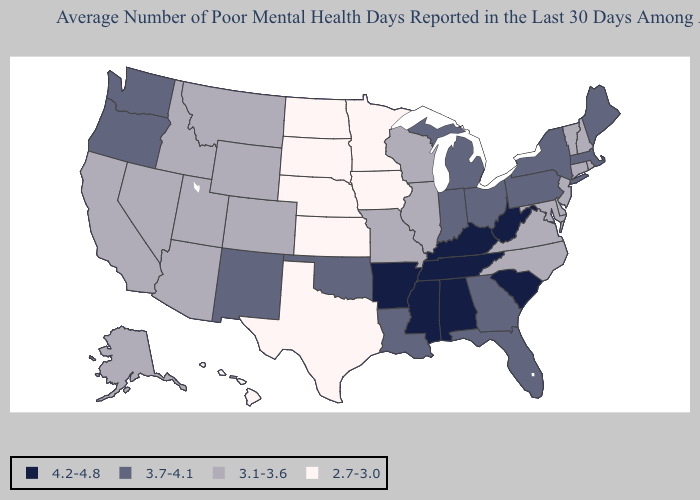Which states have the highest value in the USA?
Short answer required. Alabama, Arkansas, Kentucky, Mississippi, South Carolina, Tennessee, West Virginia. Name the states that have a value in the range 3.7-4.1?
Quick response, please. Florida, Georgia, Indiana, Louisiana, Maine, Massachusetts, Michigan, New Mexico, New York, Ohio, Oklahoma, Oregon, Pennsylvania, Washington. Which states have the highest value in the USA?
Write a very short answer. Alabama, Arkansas, Kentucky, Mississippi, South Carolina, Tennessee, West Virginia. What is the value of Missouri?
Write a very short answer. 3.1-3.6. Which states hav the highest value in the Northeast?
Be succinct. Maine, Massachusetts, New York, Pennsylvania. Name the states that have a value in the range 3.7-4.1?
Keep it brief. Florida, Georgia, Indiana, Louisiana, Maine, Massachusetts, Michigan, New Mexico, New York, Ohio, Oklahoma, Oregon, Pennsylvania, Washington. Is the legend a continuous bar?
Quick response, please. No. What is the value of Wisconsin?
Write a very short answer. 3.1-3.6. Does the first symbol in the legend represent the smallest category?
Be succinct. No. Does Michigan have the lowest value in the MidWest?
Answer briefly. No. Among the states that border Arizona , does New Mexico have the lowest value?
Keep it brief. No. Is the legend a continuous bar?
Answer briefly. No. Which states have the lowest value in the USA?
Short answer required. Hawaii, Iowa, Kansas, Minnesota, Nebraska, North Dakota, South Dakota, Texas. Name the states that have a value in the range 3.7-4.1?
Short answer required. Florida, Georgia, Indiana, Louisiana, Maine, Massachusetts, Michigan, New Mexico, New York, Ohio, Oklahoma, Oregon, Pennsylvania, Washington. What is the value of New Hampshire?
Concise answer only. 3.1-3.6. 